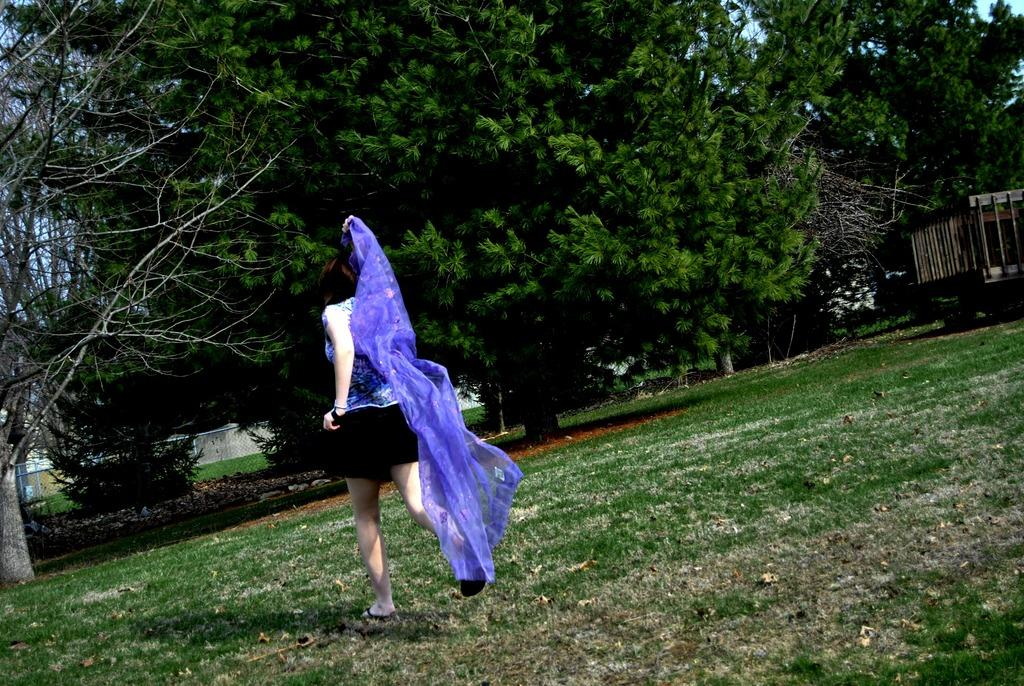Who is the main subject in the image? There is a lady in the image. What can be seen in the background of the image? There are trees and sheds in the background of the image. What is visible at the bottom of the image? The ground is visible at the bottom of the image. What type of cherry is the lady holding in the image? There is no cherry present in the image. Can you hear the lady whistling in the image? There is no indication of sound in the image, so it cannot be determined if the lady is whistling. 